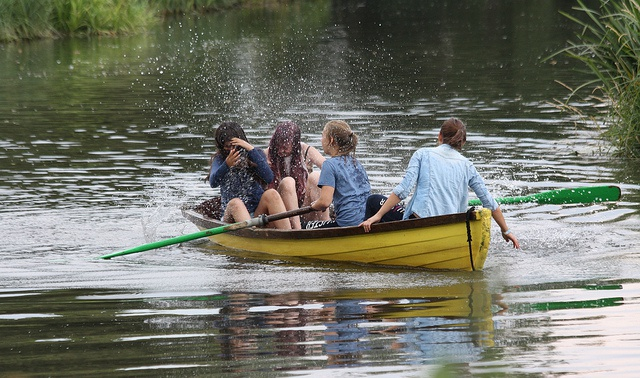Describe the objects in this image and their specific colors. I can see boat in darkgreen, olive, and black tones, people in darkgreen, lightblue, lavender, and black tones, people in darkgreen, black, gray, and tan tones, people in darkgreen, gray, and darkgray tones, and people in darkgreen, gray, black, maroon, and darkgray tones in this image. 